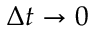Convert formula to latex. <formula><loc_0><loc_0><loc_500><loc_500>\Delta t \to 0</formula> 